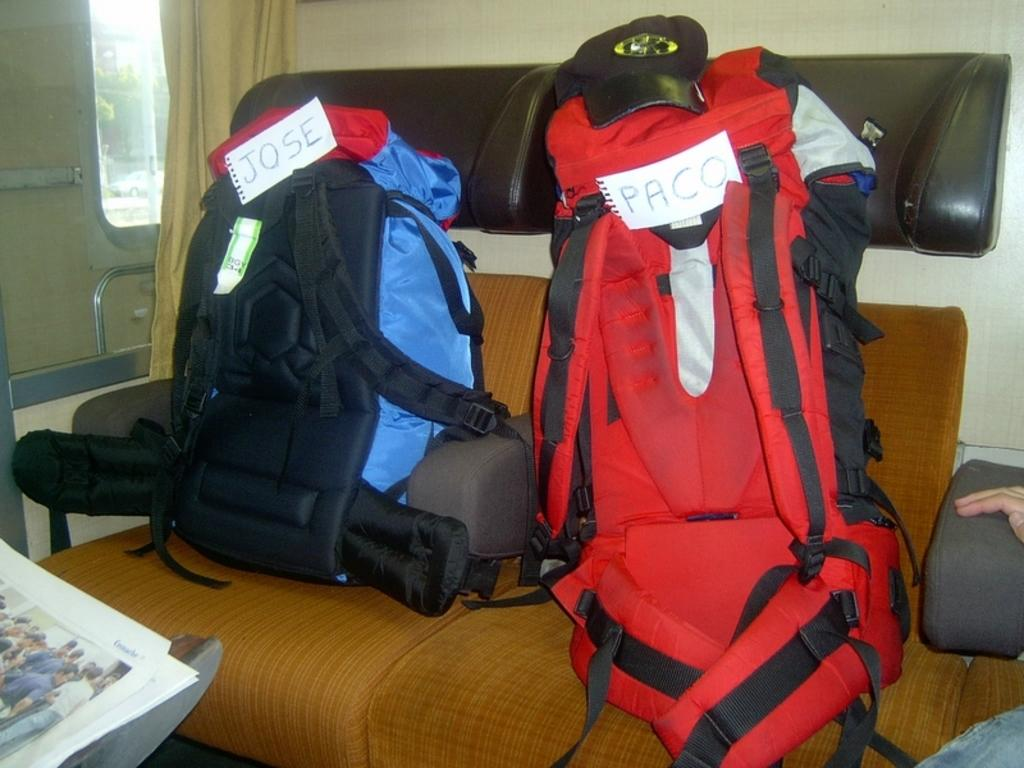Provide a one-sentence caption for the provided image. Two backpacks belong to people named Jose and Paco. 